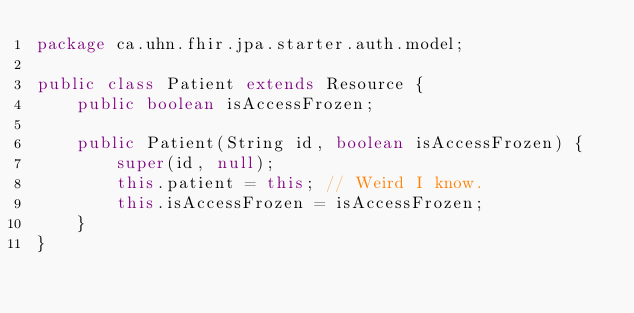<code> <loc_0><loc_0><loc_500><loc_500><_Java_>package ca.uhn.fhir.jpa.starter.auth.model;

public class Patient extends Resource {
	public boolean isAccessFrozen;

	public Patient(String id, boolean isAccessFrozen) {
		super(id, null);
		this.patient = this; // Weird I know.
		this.isAccessFrozen = isAccessFrozen;
	}
}
</code> 